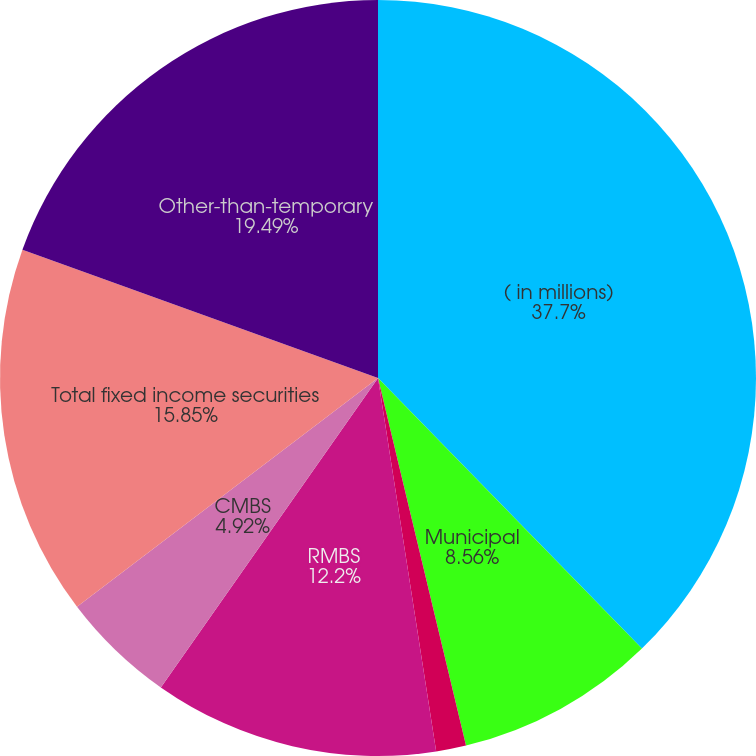<chart> <loc_0><loc_0><loc_500><loc_500><pie_chart><fcel>( in millions)<fcel>Municipal<fcel>Corporate<fcel>RMBS<fcel>CMBS<fcel>Total fixed income securities<fcel>Other-than-temporary<nl><fcel>37.7%<fcel>8.56%<fcel>1.28%<fcel>12.2%<fcel>4.92%<fcel>15.85%<fcel>19.49%<nl></chart> 